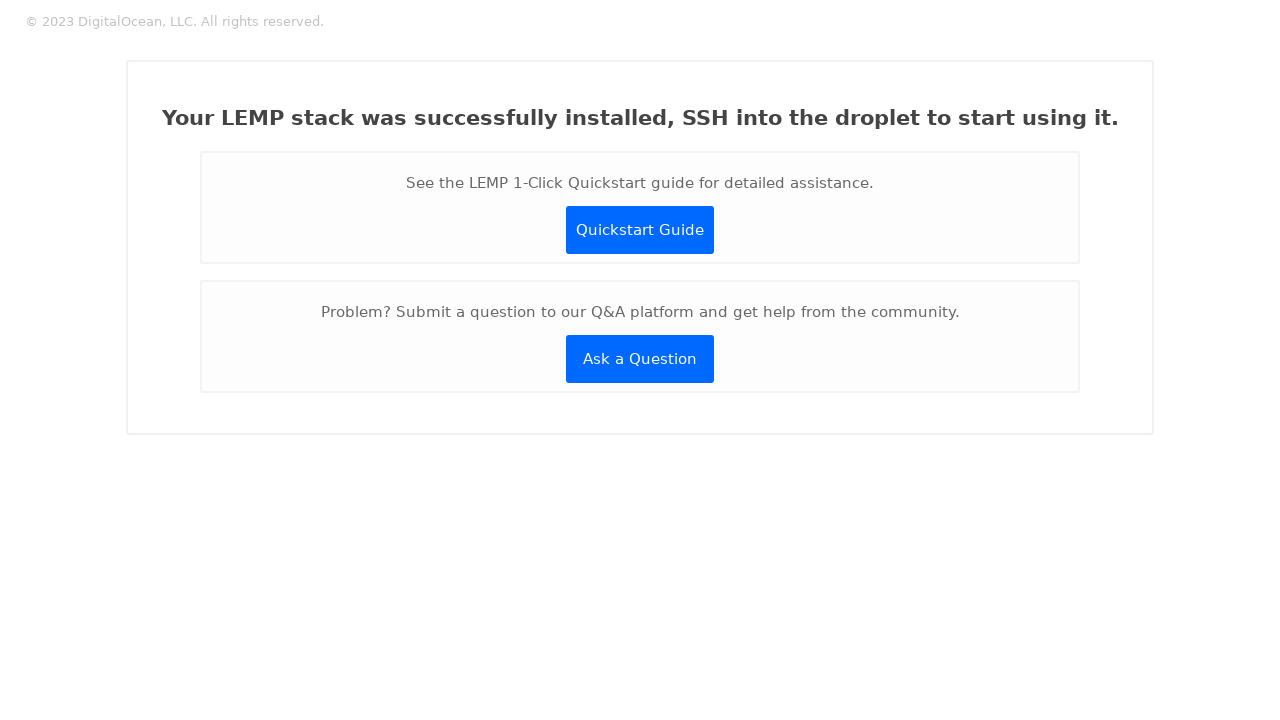Could you detail the process for assembling this website using HTML? To assemble a website similar to the one displayed post-LEMP stack installation, you would start by creating an HTML file structure outlining the basic elements like headers, divisions, and links. Next, you would use CSS for styling to make the interface clean and professional. Specifically, you'd configure classes to set fonts, alignment, and color schemes, emphasizing ease of navigation and readability. This website’s layout involves a header with copyright information, a main content area with instructional messages, and buttons for further action, all of which are crucial for guiding a new user after installation. Finally, ensure your website's design is responsive and accessible, enhancing user experience across all devices. 